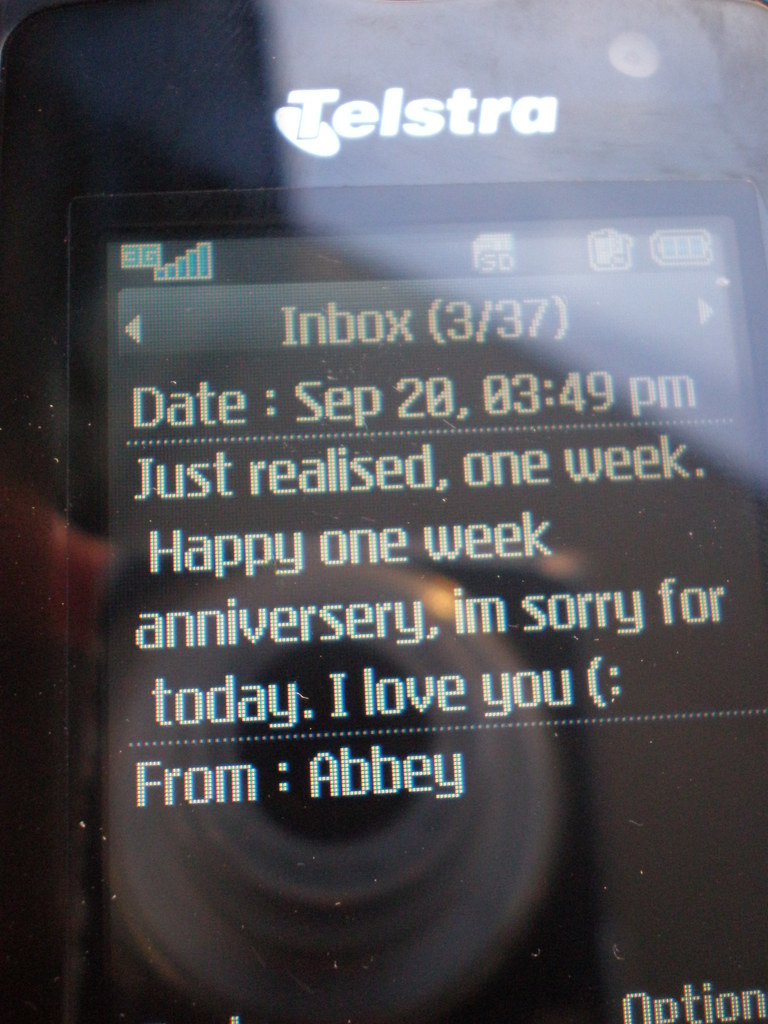Explore the emotional impact of the message seen in this image. The message in the image appears to convey a deep emotional significance, highlighted by the expression of both apology and love, suggesting a moment of repair and affection in a personal relationship. 